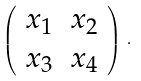Convert formula to latex. <formula><loc_0><loc_0><loc_500><loc_500>\left ( \begin{array} { c c } x _ { 1 } & x _ { 2 } \\ x _ { 3 } & x _ { 4 } \end{array} \right ) \, .</formula> 